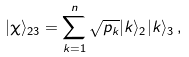Convert formula to latex. <formula><loc_0><loc_0><loc_500><loc_500>| \chi \rangle _ { 2 3 } = \sum _ { k = 1 } ^ { n } \sqrt { p _ { k } } | k \rangle _ { 2 } | k \rangle _ { 3 } \, ,</formula> 